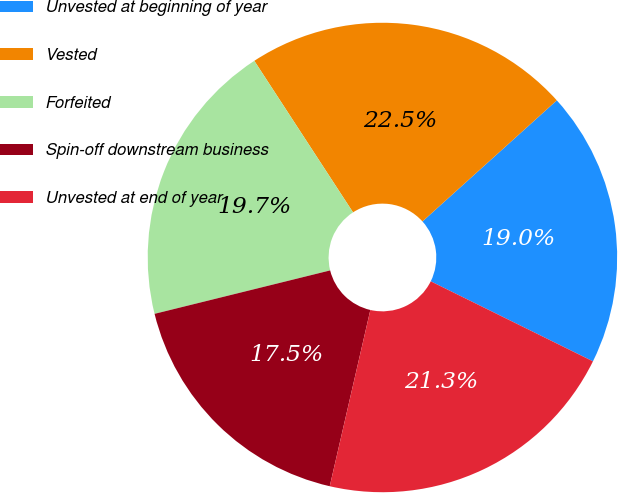<chart> <loc_0><loc_0><loc_500><loc_500><pie_chart><fcel>Unvested at beginning of year<fcel>Vested<fcel>Forfeited<fcel>Spin-off downstream business<fcel>Unvested at end of year<nl><fcel>18.97%<fcel>22.52%<fcel>19.67%<fcel>17.54%<fcel>21.31%<nl></chart> 